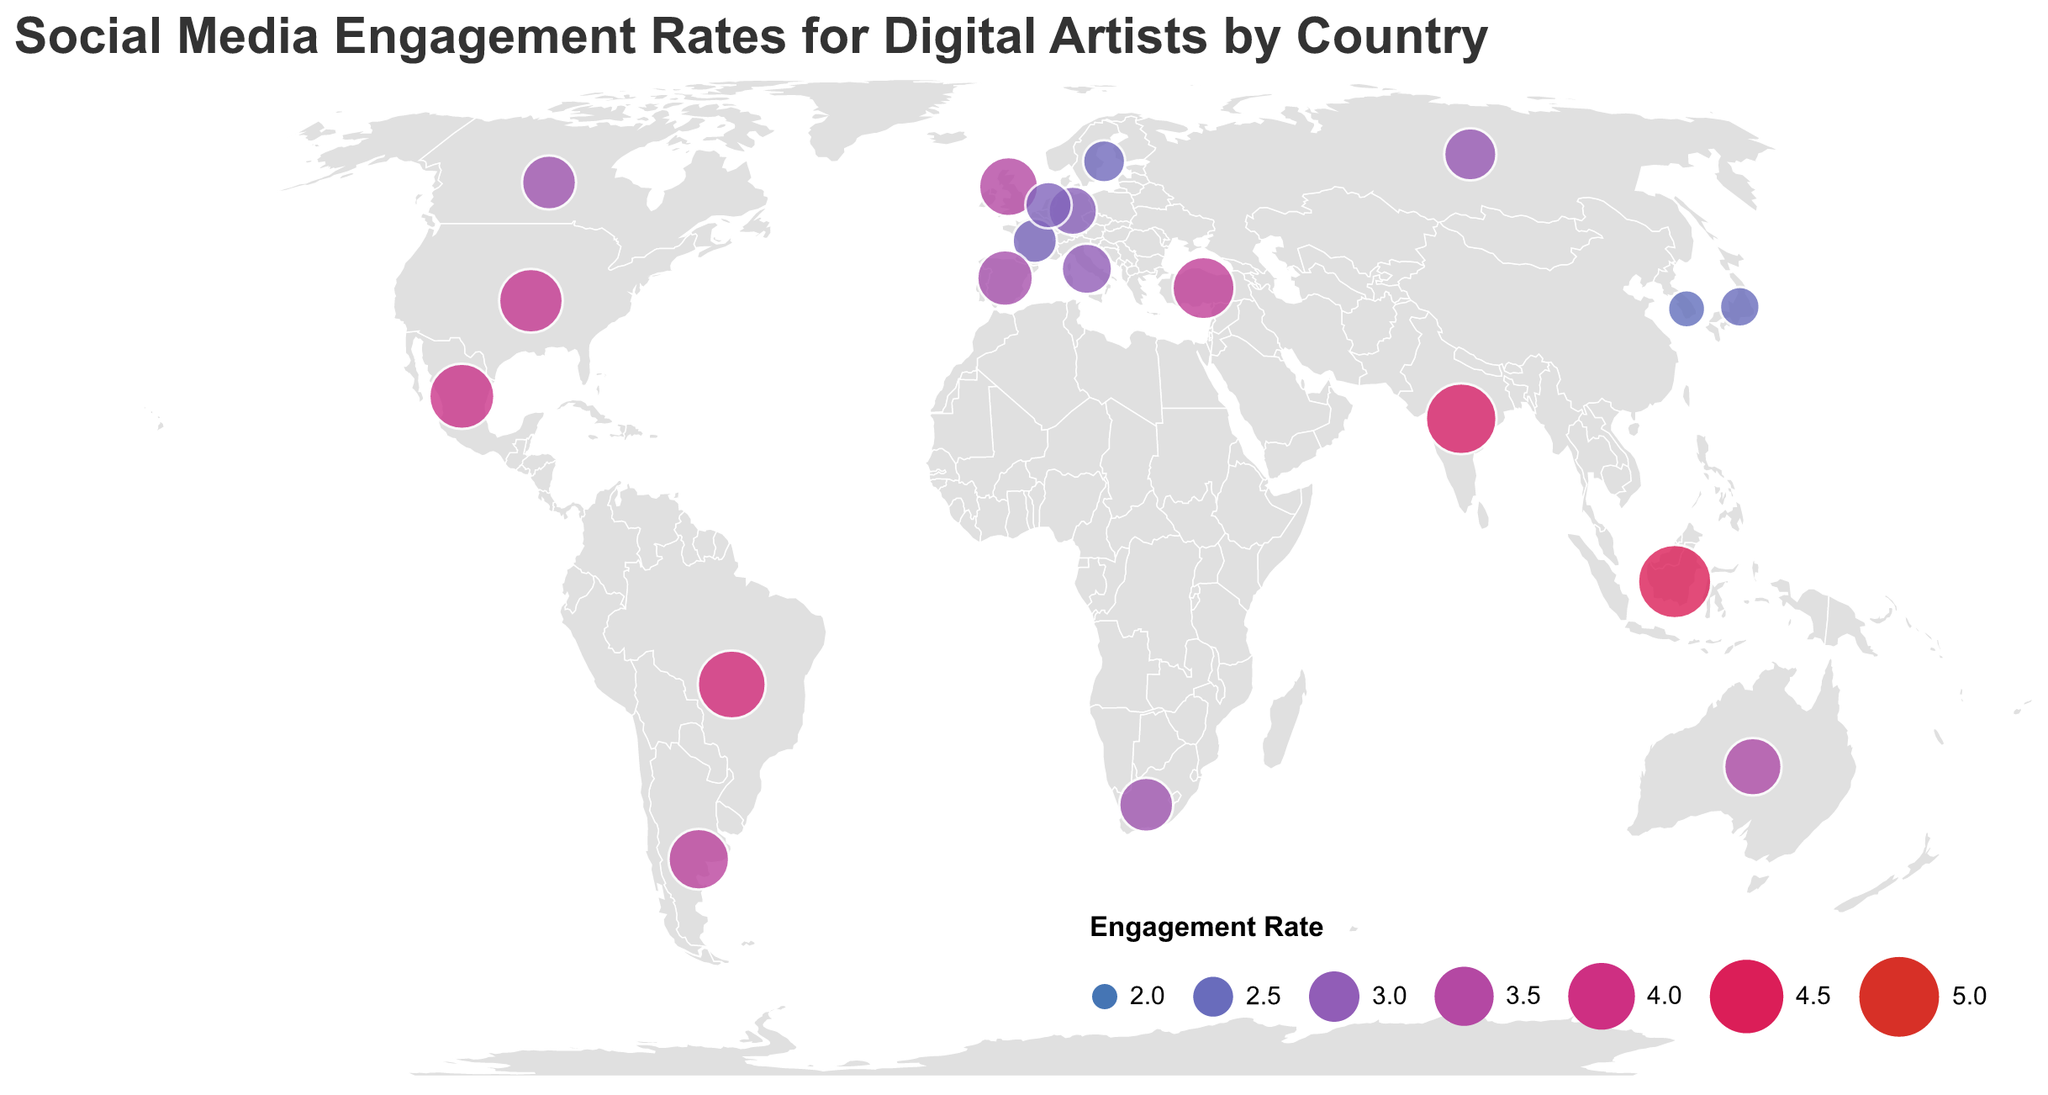Which country has the highest engagement rate? Look at the countries on the map and identify which has the largest circle, as the size represents the engagement rate. Indonesia, with an engagement rate of 4.5, has the highest rate.
Answer: Indonesia Which country has the lowest engagement rate? Look for the smallest circle on the map, since smaller circles represent lower engagement rates. South Korea, with an engagement rate of 2.4, has the lowest rate.
Answer: South Korea What is the average engagement rate for the countries in Europe? Identify the European countries and their engagement rates (United Kingdom 3.5, Germany 2.9, France 2.7, Spain 3.3, Italy 3.0, Netherlands 2.8, Sweden 2.6, Russia 3.1). Sum these rates (3.5 + 2.9 + 2.7 + 3.3 + 3.0 + 2.8 + 2.6 + 3.1 = 24.9). There are 8 countries, so the average rate is 24.9 / 8.
Answer: 3.11 Which continent seems to have the highest variability in engagement rates? Identify the continent with the most varied circle sizes (covers both large and small circles). Asia, consisting of countries with both high (India 4.3, Indonesia 4.5) and low (Japan 2.5, South Korea 2.4) engagement rates, exhibits the highest variability.
Answer: Asia How many countries have an engagement rate of 4.0 or higher? Count the circles with sizes representing engagement rates of 4.0 or higher. The countries with these rates are Brazil (4.1), India (4.3), Mexico (3.9), and Indonesia (4.5). However, Mexico has 3.9 which is less than 4.0, so it does not count. Hence, the count of countries is 3.
Answer: 3 Compare the engagement rates of the United States and Brazil. Which one is higher and by how much? Identify the engagement rates for both countries (United States 3.8, Brazil 4.1). Subtract the engagement rate of the United States from that of Brazil (4.1 - 3.8 = 0.3). So, Brazil's rate is higher by 0.3.
Answer: Brazil by 0.3 What is the approximate engagement rate pattern in terms of color and size on the map? Engagement rates are represented by both color and size; higher engagement rates are depicted by larger circles which tend to be more reddish, whereas lower rates are depicted by smaller and more bluish circles.
Answer: Larger & red equals higher, smaller & blue equals lower 